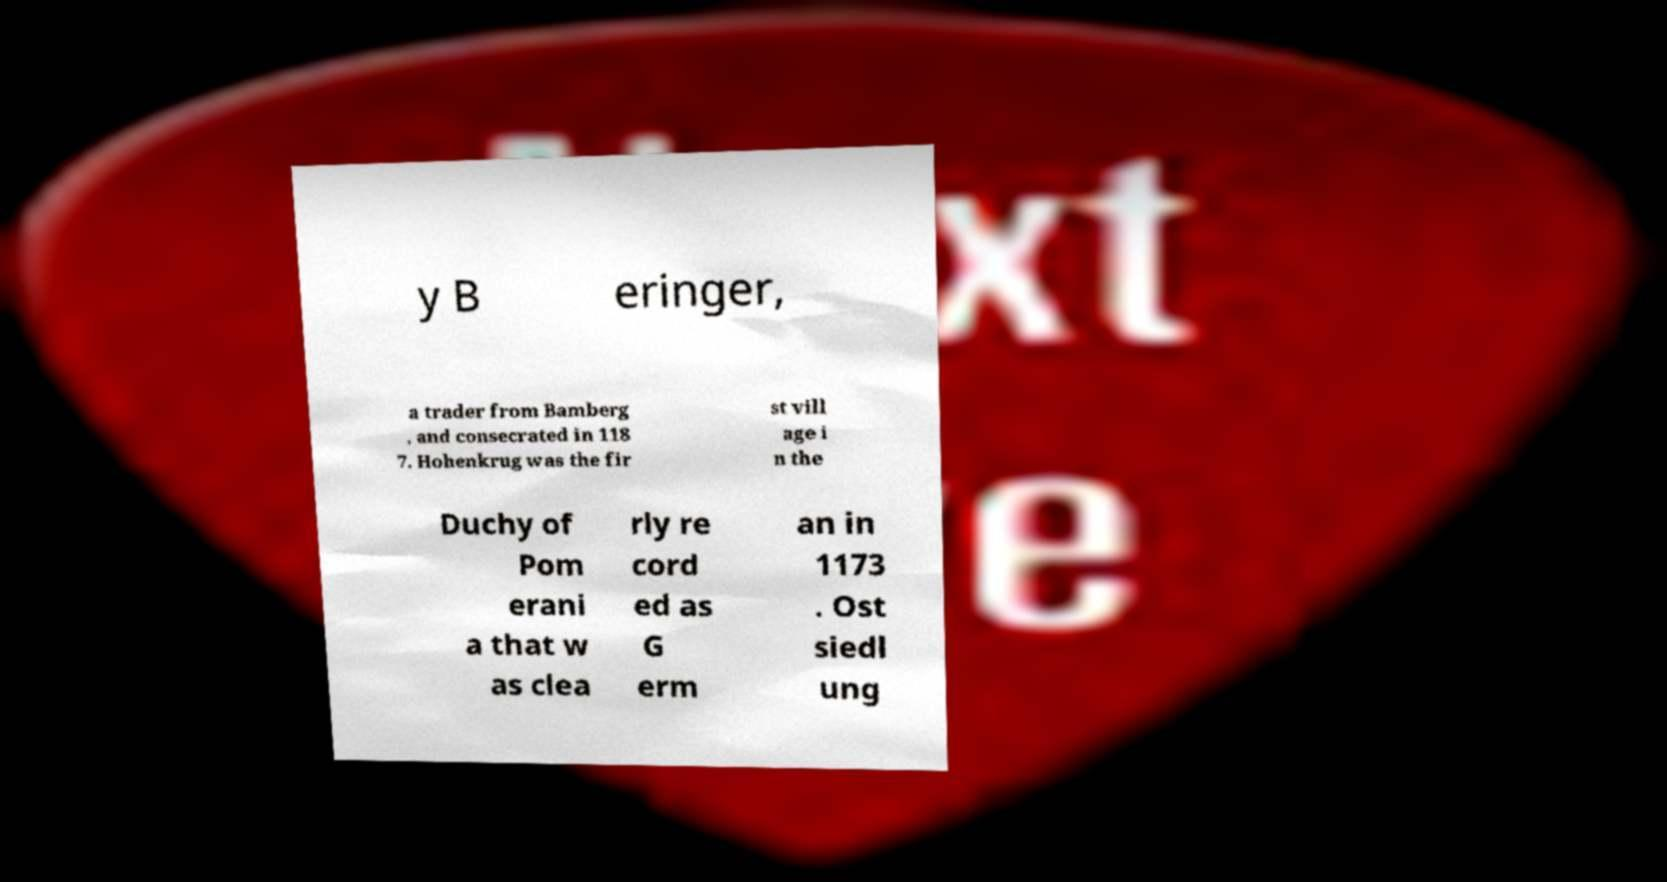Please read and relay the text visible in this image. What does it say? y B eringer, a trader from Bamberg , and consecrated in 118 7. Hohenkrug was the fir st vill age i n the Duchy of Pom erani a that w as clea rly re cord ed as G erm an in 1173 . Ost siedl ung 